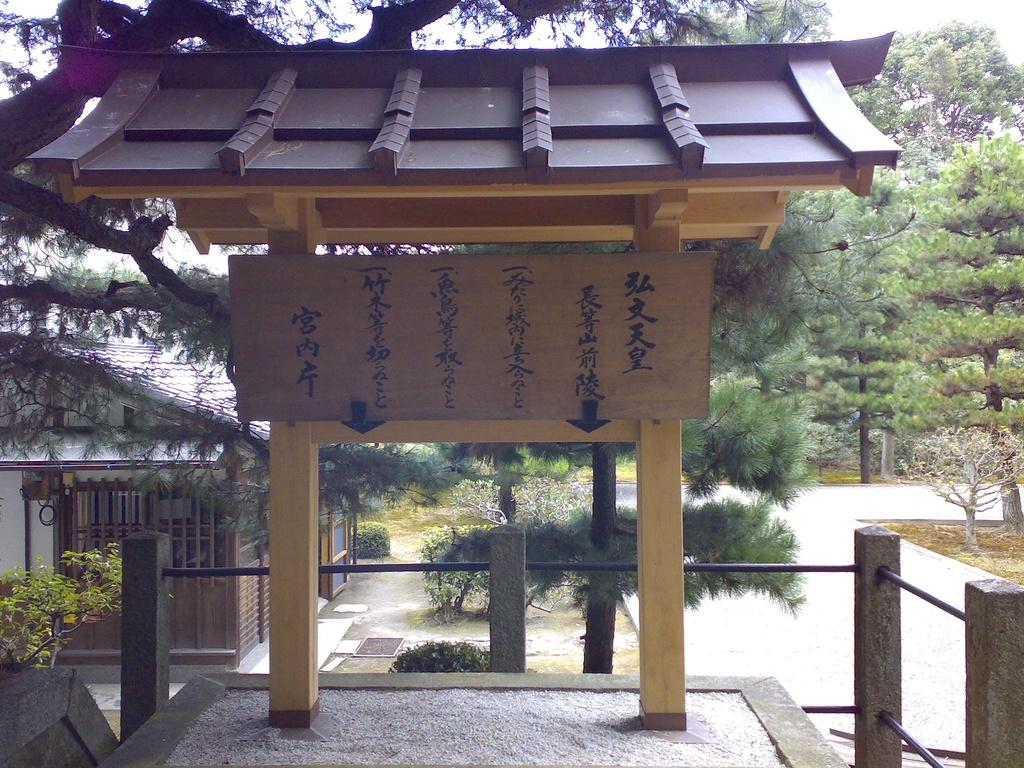What type of structure is in the image? There is a wooden shed in the image. What language is written on the shed? Chinese language is written on the shed. What can be seen in the background of the image? There are trees in the background of the image. How many pins are attached to the bird in the image? There is no bird present in the image, so it is not possible to determine the number of pins attached to it. 